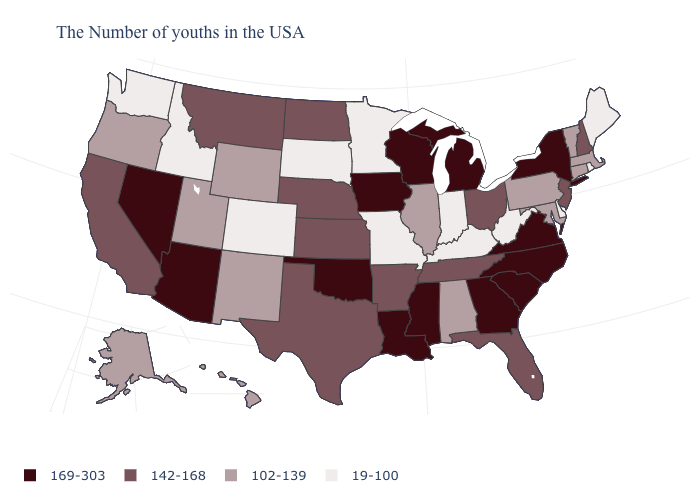Does California have the same value as Arkansas?
Keep it brief. Yes. What is the value of Utah?
Keep it brief. 102-139. Name the states that have a value in the range 102-139?
Short answer required. Massachusetts, Vermont, Connecticut, Maryland, Pennsylvania, Alabama, Illinois, Wyoming, New Mexico, Utah, Oregon, Alaska, Hawaii. Is the legend a continuous bar?
Answer briefly. No. What is the value of Montana?
Quick response, please. 142-168. What is the value of Missouri?
Be succinct. 19-100. What is the value of Oklahoma?
Keep it brief. 169-303. Which states have the lowest value in the USA?
Answer briefly. Maine, Rhode Island, Delaware, West Virginia, Kentucky, Indiana, Missouri, Minnesota, South Dakota, Colorado, Idaho, Washington. Does Mississippi have the highest value in the USA?
Answer briefly. Yes. How many symbols are there in the legend?
Answer briefly. 4. Name the states that have a value in the range 19-100?
Quick response, please. Maine, Rhode Island, Delaware, West Virginia, Kentucky, Indiana, Missouri, Minnesota, South Dakota, Colorado, Idaho, Washington. Name the states that have a value in the range 102-139?
Quick response, please. Massachusetts, Vermont, Connecticut, Maryland, Pennsylvania, Alabama, Illinois, Wyoming, New Mexico, Utah, Oregon, Alaska, Hawaii. Among the states that border North Carolina , which have the lowest value?
Write a very short answer. Tennessee. Does the first symbol in the legend represent the smallest category?
Short answer required. No. What is the lowest value in the USA?
Keep it brief. 19-100. 